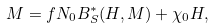<formula> <loc_0><loc_0><loc_500><loc_500>M = f N _ { 0 } B _ { S } ^ { * } ( H , M ) + \chi _ { 0 } H ,</formula> 